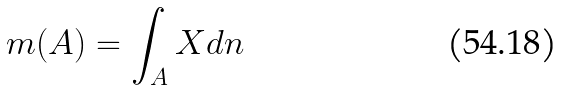Convert formula to latex. <formula><loc_0><loc_0><loc_500><loc_500>m ( A ) = \int _ { A } X d n</formula> 